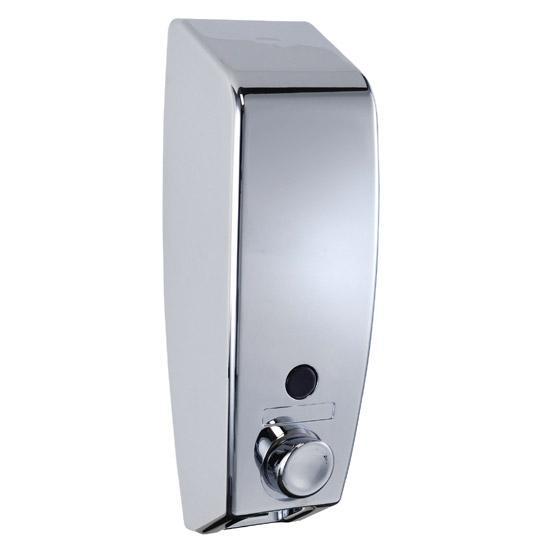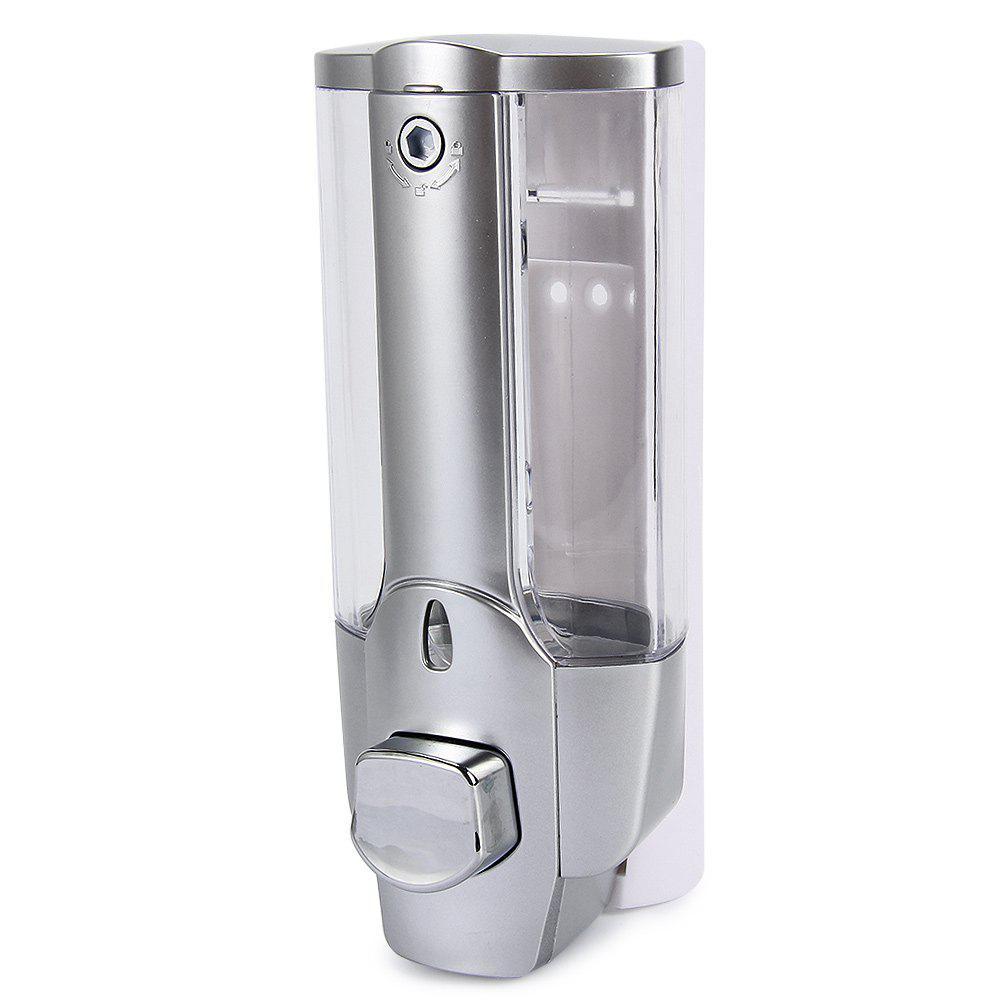The first image is the image on the left, the second image is the image on the right. For the images displayed, is the sentence "One or more of the dispensers has a chrome finish." factually correct? Answer yes or no. Yes. 